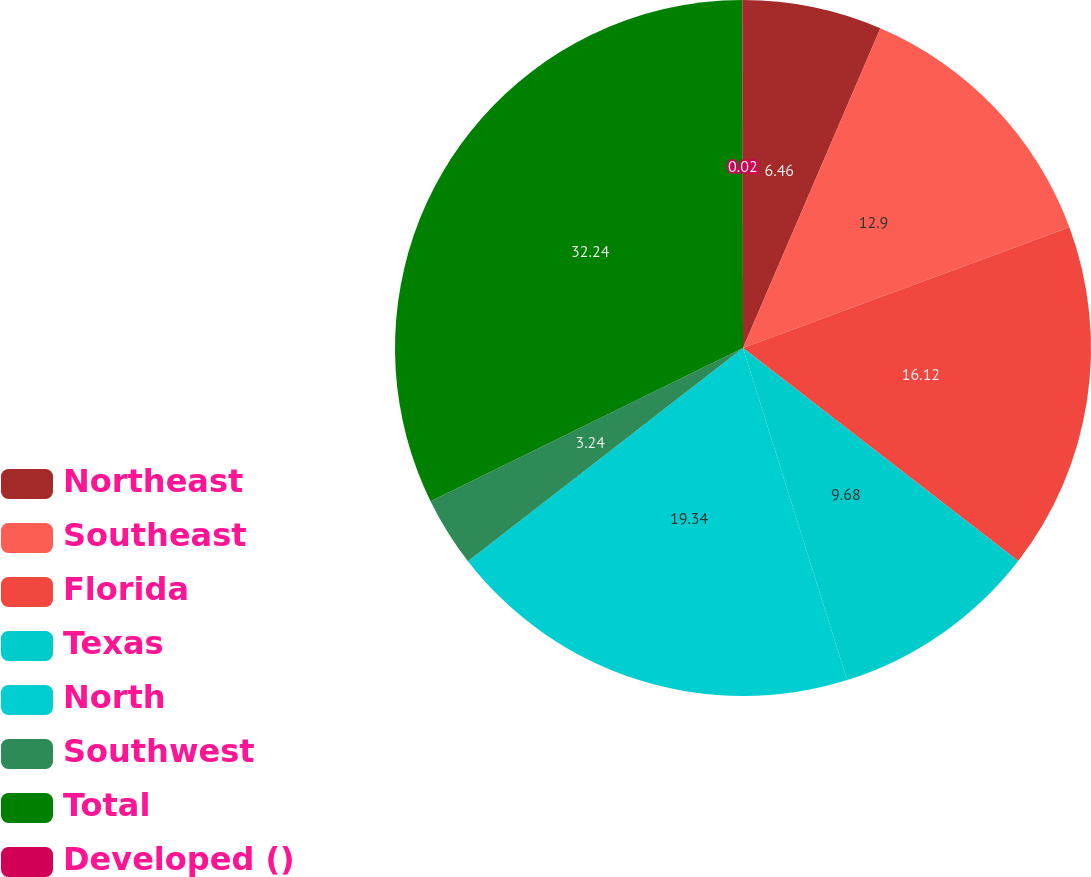Convert chart. <chart><loc_0><loc_0><loc_500><loc_500><pie_chart><fcel>Northeast<fcel>Southeast<fcel>Florida<fcel>Texas<fcel>North<fcel>Southwest<fcel>Total<fcel>Developed ()<nl><fcel>6.46%<fcel>12.9%<fcel>16.12%<fcel>9.68%<fcel>19.34%<fcel>3.24%<fcel>32.23%<fcel>0.02%<nl></chart> 